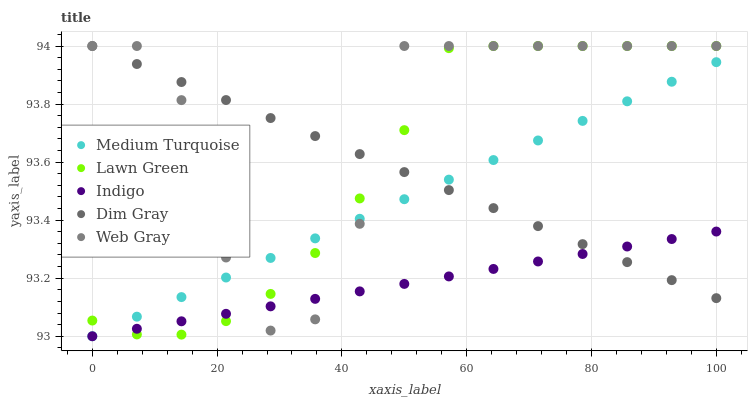Does Indigo have the minimum area under the curve?
Answer yes or no. Yes. Does Web Gray have the maximum area under the curve?
Answer yes or no. Yes. Does Lawn Green have the minimum area under the curve?
Answer yes or no. No. Does Lawn Green have the maximum area under the curve?
Answer yes or no. No. Is Medium Turquoise the smoothest?
Answer yes or no. Yes. Is Web Gray the roughest?
Answer yes or no. Yes. Is Lawn Green the smoothest?
Answer yes or no. No. Is Lawn Green the roughest?
Answer yes or no. No. Does Indigo have the lowest value?
Answer yes or no. Yes. Does Lawn Green have the lowest value?
Answer yes or no. No. Does Dim Gray have the highest value?
Answer yes or no. Yes. Does Indigo have the highest value?
Answer yes or no. No. Does Web Gray intersect Lawn Green?
Answer yes or no. Yes. Is Web Gray less than Lawn Green?
Answer yes or no. No. Is Web Gray greater than Lawn Green?
Answer yes or no. No. 